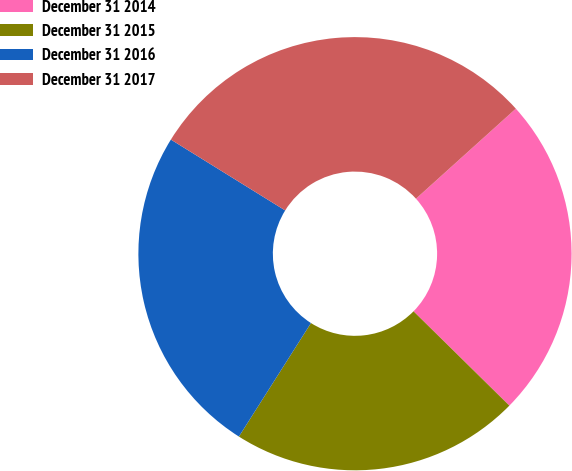<chart> <loc_0><loc_0><loc_500><loc_500><pie_chart><fcel>December 31 2014<fcel>December 31 2015<fcel>December 31 2016<fcel>December 31 2017<nl><fcel>24.05%<fcel>21.63%<fcel>24.83%<fcel>29.49%<nl></chart> 